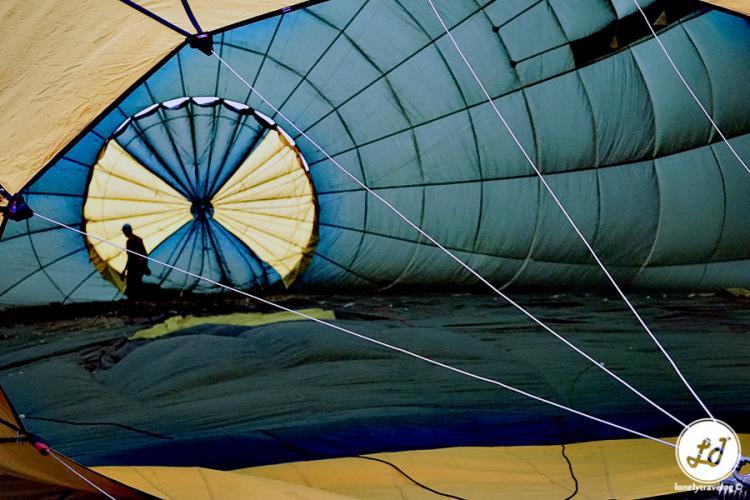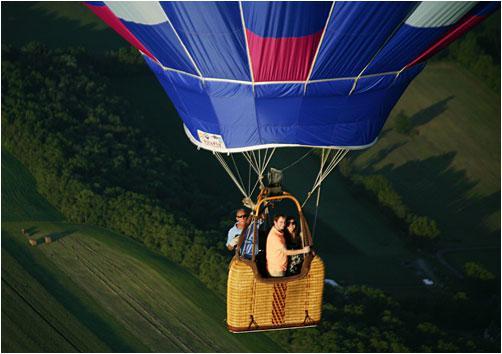The first image is the image on the left, the second image is the image on the right. Given the left and right images, does the statement "An image shows the interior of a balloon which is lying on the ground." hold true? Answer yes or no. Yes. The first image is the image on the left, the second image is the image on the right. For the images shown, is this caption "One image shows a single balloon in midair with people in its basket and a view of the landscape under it including green areas." true? Answer yes or no. Yes. 